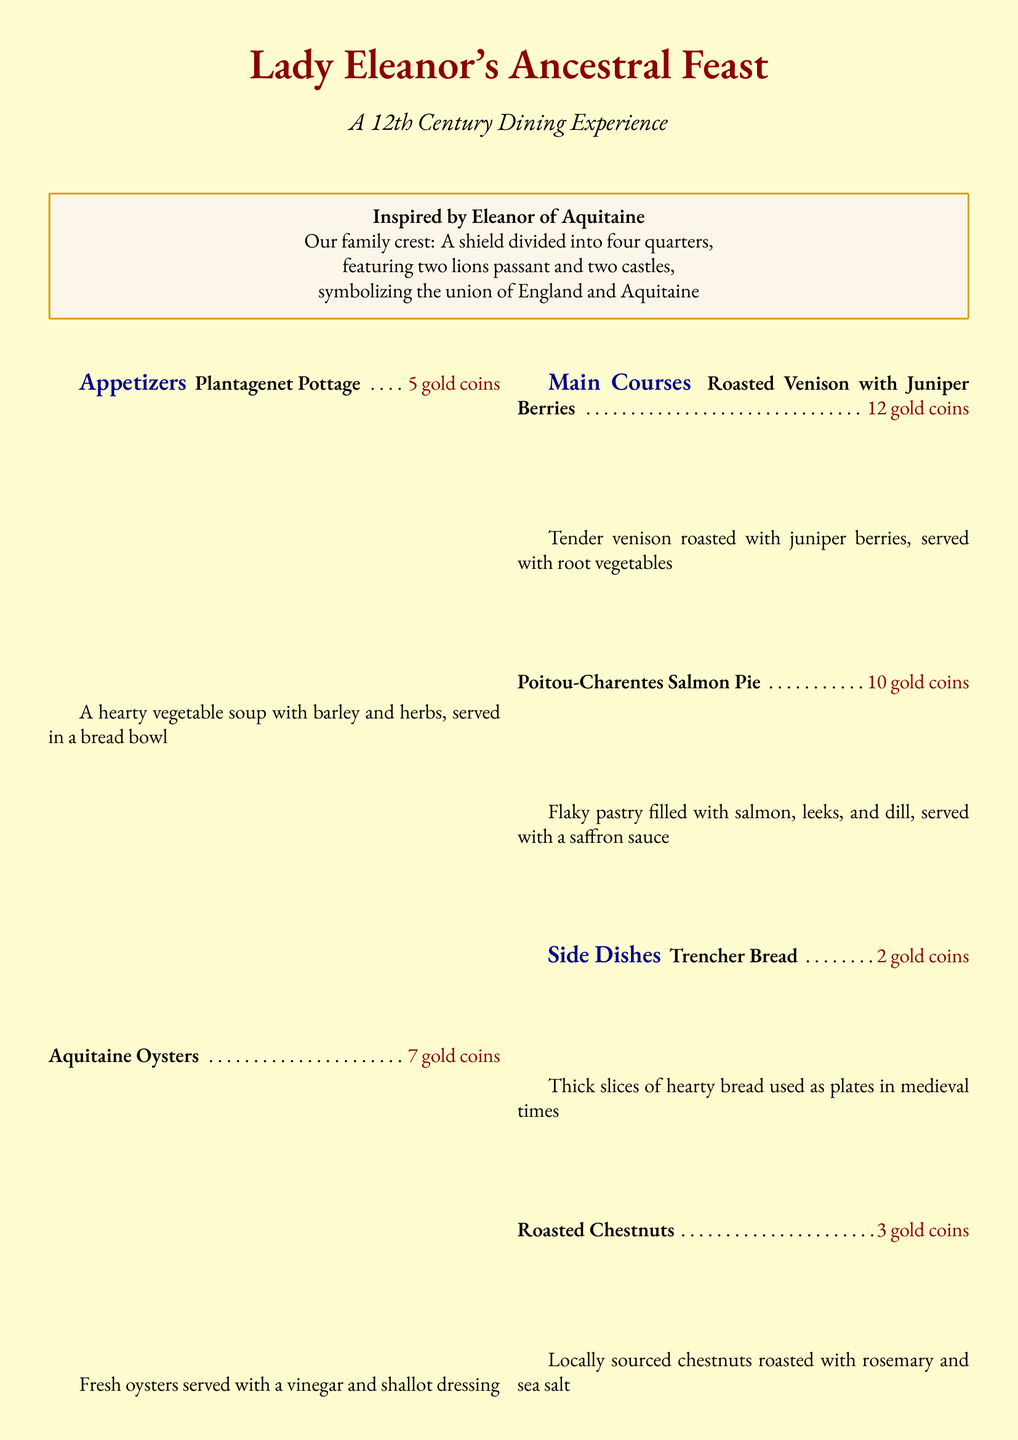What is the name of the feast? The feast is named after Lady Eleanor and reflects her influence.
Answer: Lady Eleanor's Ancestral Feast What is the main historical inspiration for the menu? The menu is inspired by a significant figure from the 12th century.
Answer: Eleanor of Aquitaine How many gold coins do the Aquitaine Oysters cost? The cost of the dish is listed in gold coins.
Answer: 7 gold coins What type of meat is used in the Roasted Venison dish? The dish name indicates the type of meat served.
Answer: Venison What is the price of the Plantagenet Mead? The menu lists prices next to each beverage.
Answer: 4 gold coins What type of soup is offered as an appetizer? The name of the dish provides information on its ingredients and type.
Answer: Vegetable soup Which dessert features candied violets? The dish description mentions the specific topping used.
Answer: Aquitaine Almond Custard How many appetizers are listed on the menu? The total number of appetizers can be counted directly from the menu section.
Answer: 2 appetizers What herb is included in Eleanor's Herbal Tisane? The specific herbs used in the tisane are listed in its description.
Answer: Chamomile 